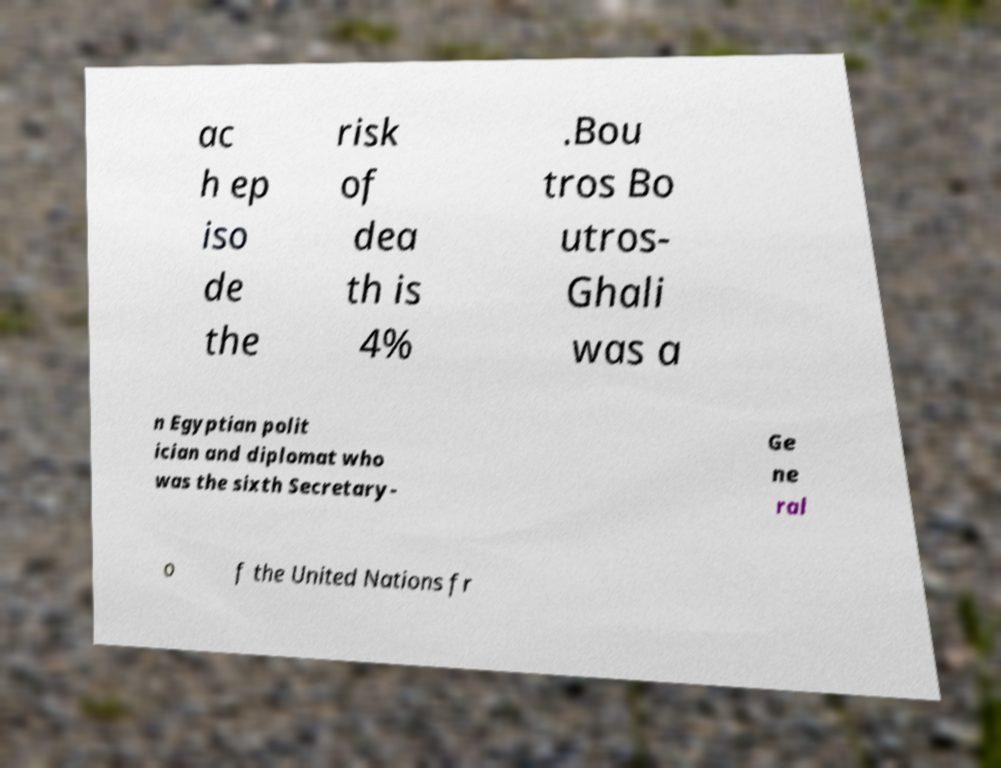Please read and relay the text visible in this image. What does it say? ac h ep iso de the risk of dea th is 4% .Bou tros Bo utros- Ghali was a n Egyptian polit ician and diplomat who was the sixth Secretary- Ge ne ral o f the United Nations fr 